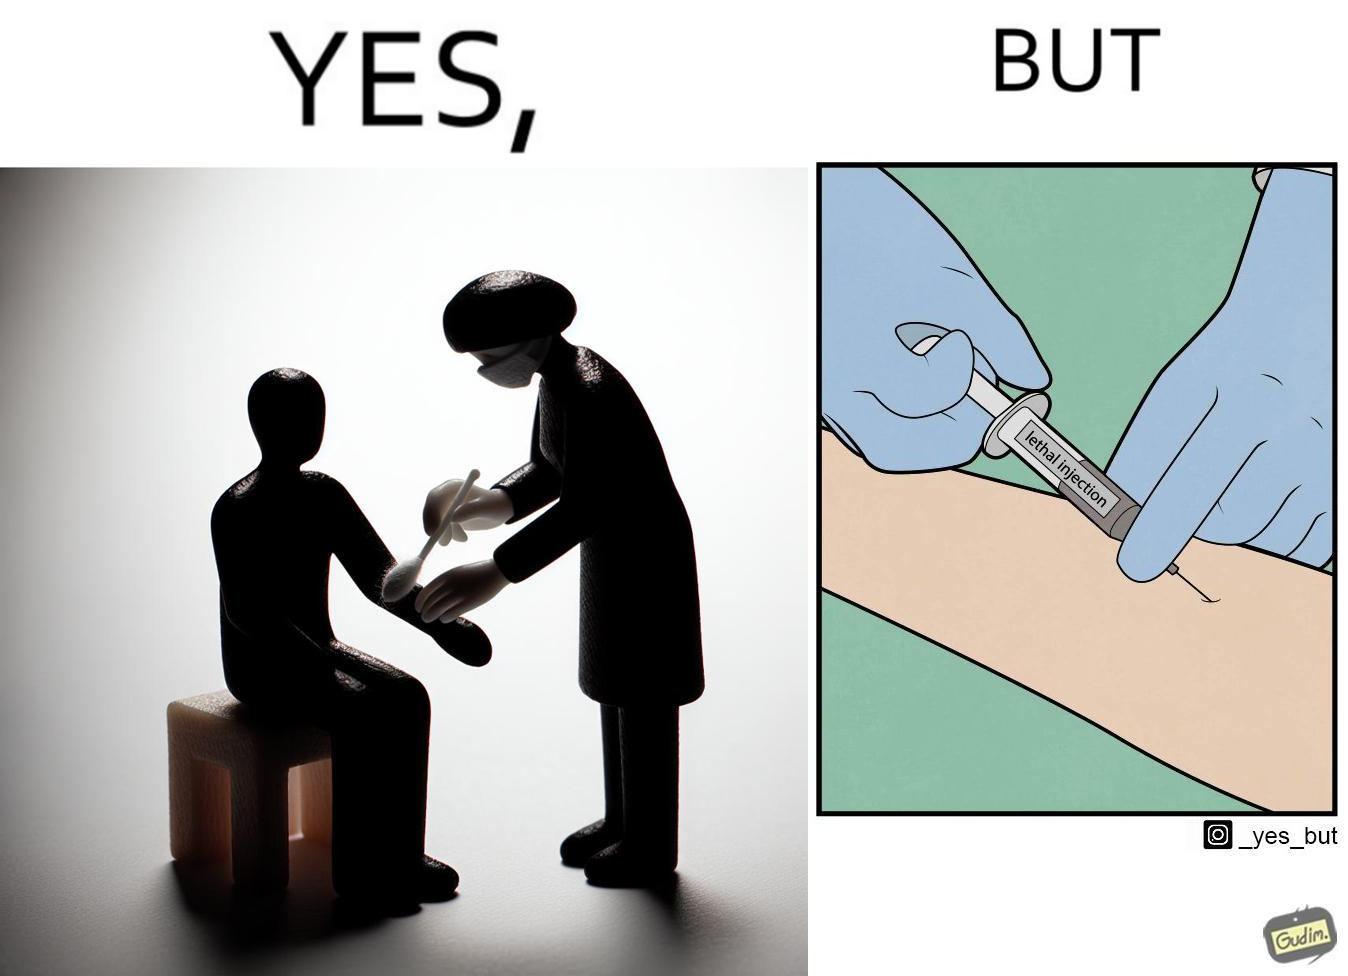Describe what you see in this image. The image is ironical, as rubbing alcohol is used to clean a place on the arm for giving an injection, while the injection itself is 'lethal'. 